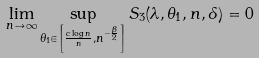Convert formula to latex. <formula><loc_0><loc_0><loc_500><loc_500>\lim _ { n \to \infty } \sup _ { \theta _ { 1 } \in \left [ \frac { c \log n } { n } , n ^ { - \frac { \beta } { 2 } } \right ] } S _ { 3 } ( \lambda , \theta _ { 1 } , n , \delta ) = 0</formula> 